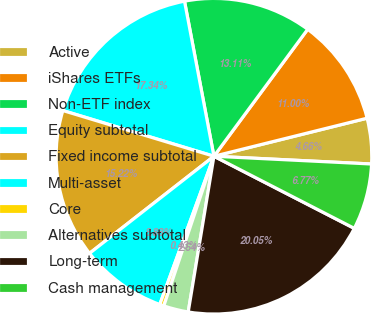<chart> <loc_0><loc_0><loc_500><loc_500><pie_chart><fcel>Active<fcel>iShares ETFs<fcel>Non-ETF index<fcel>Equity subtotal<fcel>Fixed income subtotal<fcel>Multi-asset<fcel>Core<fcel>Alternatives subtotal<fcel>Long-term<fcel>Cash management<nl><fcel>4.66%<fcel>11.0%<fcel>13.11%<fcel>17.34%<fcel>15.22%<fcel>8.88%<fcel>0.43%<fcel>2.54%<fcel>20.05%<fcel>6.77%<nl></chart> 